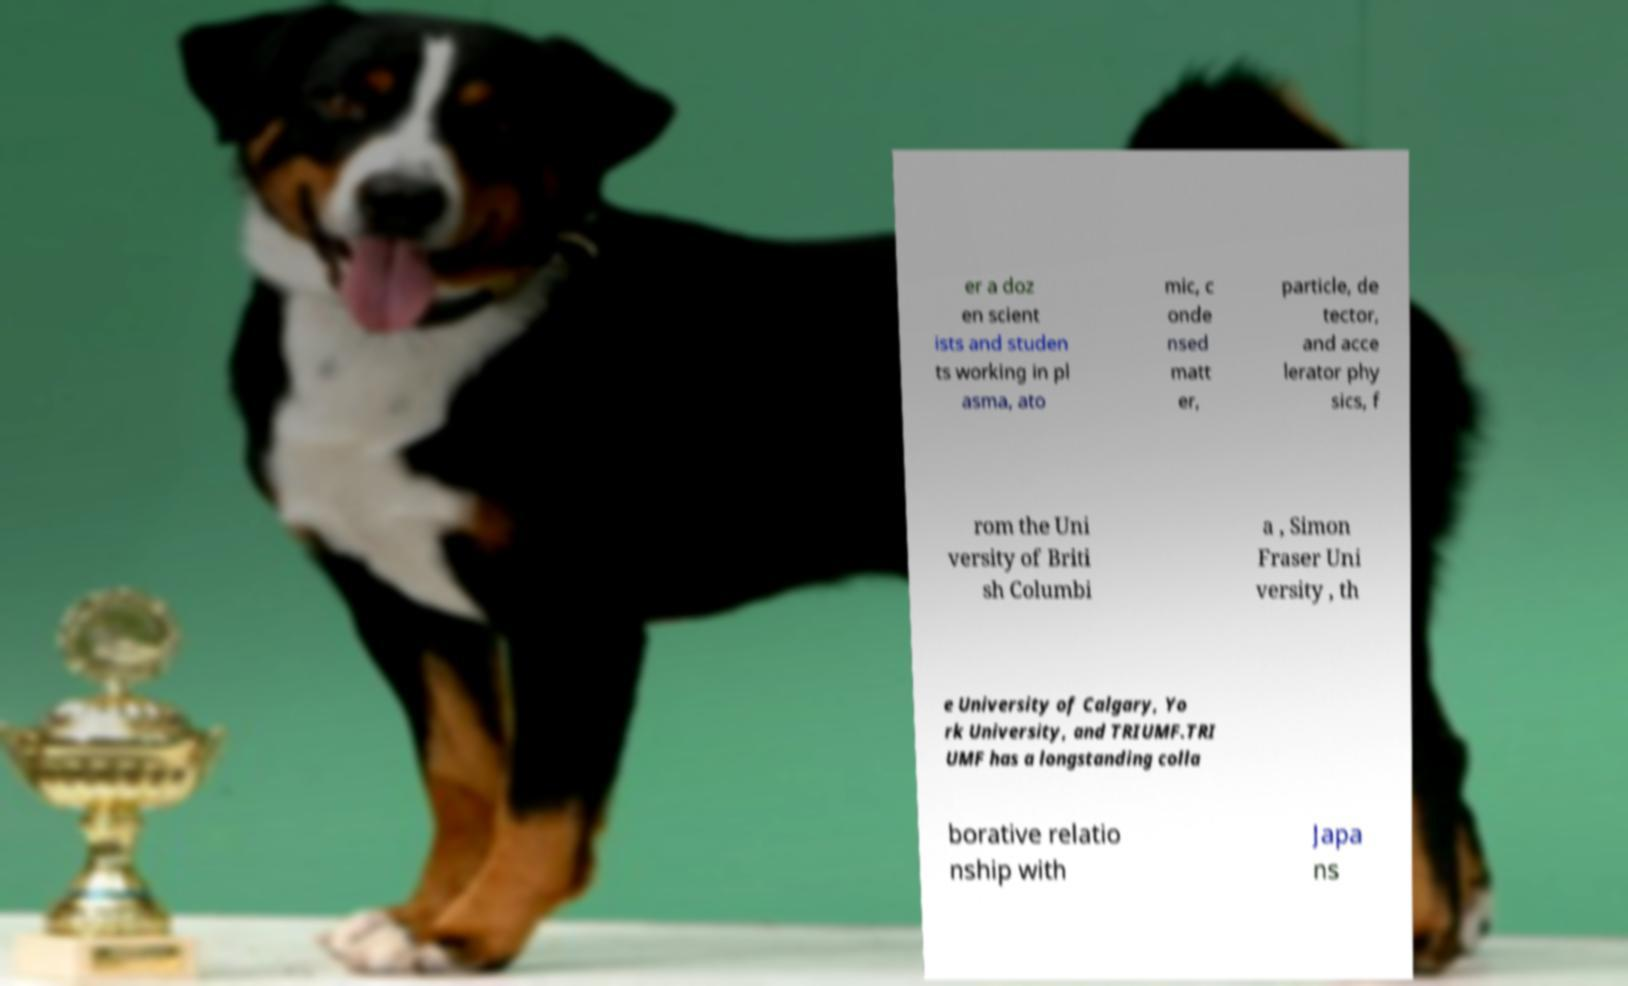There's text embedded in this image that I need extracted. Can you transcribe it verbatim? er a doz en scient ists and studen ts working in pl asma, ato mic, c onde nsed matt er, particle, de tector, and acce lerator phy sics, f rom the Uni versity of Briti sh Columbi a , Simon Fraser Uni versity , th e University of Calgary, Yo rk University, and TRIUMF.TRI UMF has a longstanding colla borative relatio nship with Japa ns 